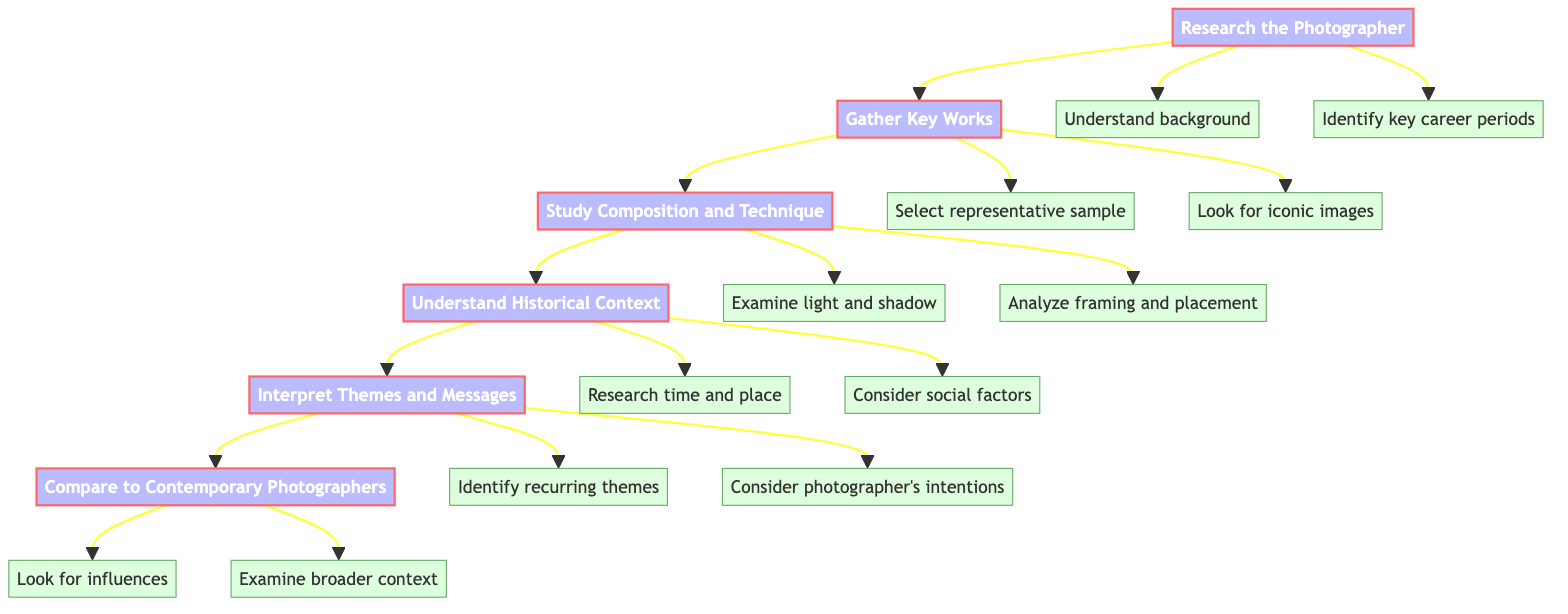What is the first step in the analysis process? The diagram clearly indicates that the first step in the process of analyzing the work of influential street photographers is "Research the Photographer."
Answer: Research the Photographer How many details are associated with the step "Gather Key Works"? By examining the diagram, we can see that the step "Gather Key Works" leads to two details: "Select a representative sample of their photos" and "Look for iconic images," which makes a total of two details.
Answer: 2 Which step follows "Study Composition and Technique"? The flow of the diagram shows that "Study Composition and Technique" is followed directly by "Understand Historical Context."
Answer: Understand Historical Context What are the two details under the step "Interpret Themes and Messages"? The diagram lists two details under "Interpret Themes and Messages": "Identify recurring themes in the work" and "Consider the photographer’s intentions."
Answer: Identify recurring themes in the work, Consider the photographer's intentions What step comes before "Compare to Contemporary Photographers"? In the order of the nodes presented in the diagram, the step that comes before "Compare to Contemporary Photographers" is "Interpret Themes and Messages."
Answer: Interpret Themes and Messages How many total steps are represented in the diagram? By counting the main steps noted within the diagram—Research the Photographer, Gather Key Works, Study Composition and Technique, Understand Historical Context, Interpret Themes and Messages, and Compare to Contemporary Photographers—we find there are six steps in total.
Answer: 6 Which detail is linked to the step "Study Composition and Technique" focusing on layout? Among the details listed for the step "Study Composition and Technique," the one that specifically addresses layout is "Analyze framing and subject placement."
Answer: Analyze framing and subject placement How does "Understand Historical Context" relate to the overall analysis process? The diagram shows that "Understand Historical Context" is a crucial step that provides insight into the time, place, and external factors influencing the photographs, which is essential for comprehensive analysis. It is part of a sequential flow leading to deeper interpretation.
Answer: It provides insight into time, place, and external factors 